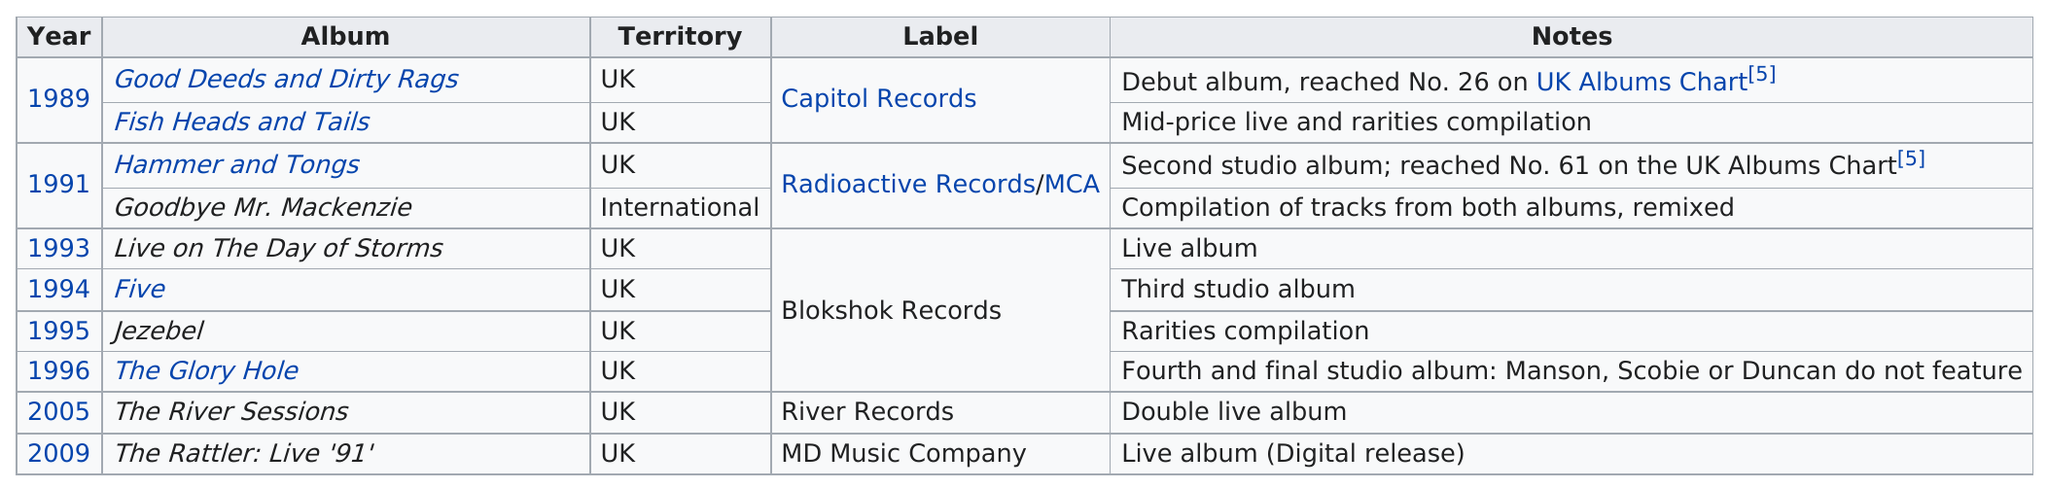Identify some key points in this picture. The album produced by River Records for the group is the only one, it is called "The River Sessions. The Blokshok Records label released 4 consecutive albums. In 1995, the album "Jezebel" was released on Blockshok Records. The next album listed after 1993 is Five.. The group had a total of 2 albums under Capitol Records. 